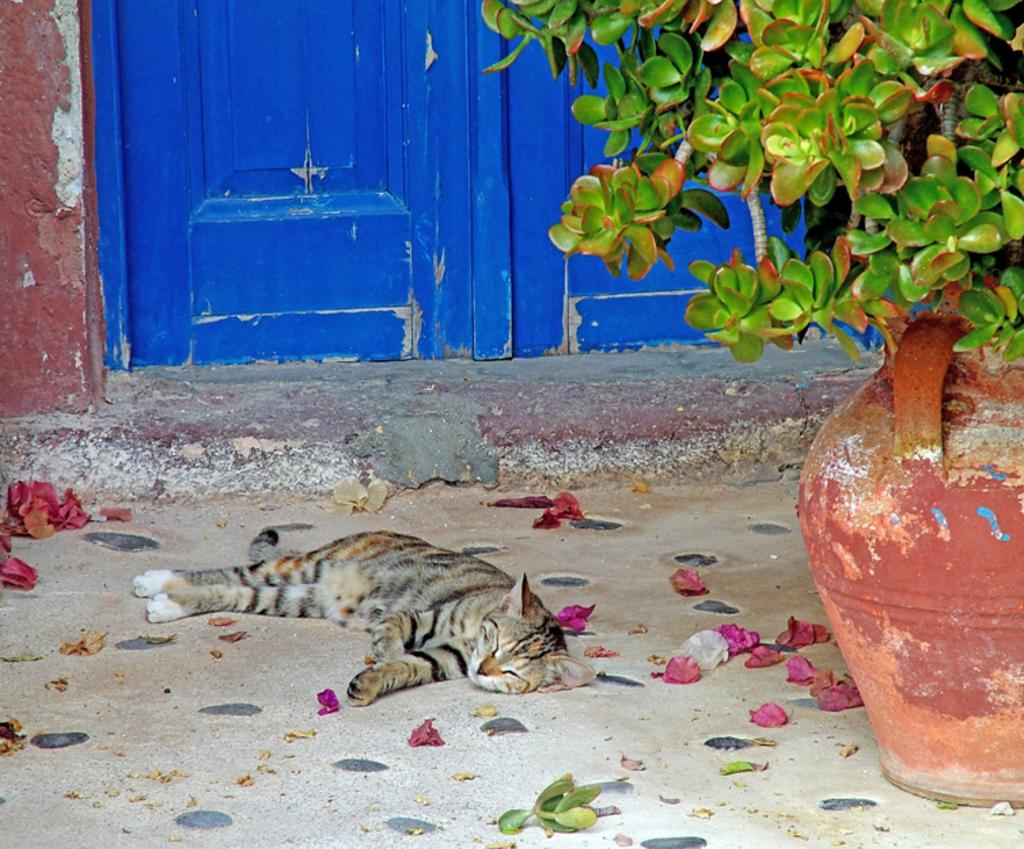What animal can be seen lying on the path in the image? There is a cat lying on the path in the image. What else is present on the path besides the cat? There are leaves on the path. What can be seen on the right side of the image? There is a flower pot on the right side of the image. What is visible in the background of the image? There is a door and a wall in the background of the image. How many alleys can be seen in the image? There is no alley present in the image. What is the amount of sky visible in the image? The image does not show the sky, so it is not possible to determine the amount of sky visible. 